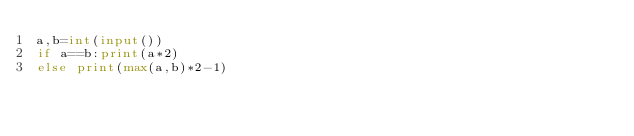<code> <loc_0><loc_0><loc_500><loc_500><_Python_>a,b=int(input())
if a==b:print(a*2)
else print(max(a,b)*2-1)</code> 